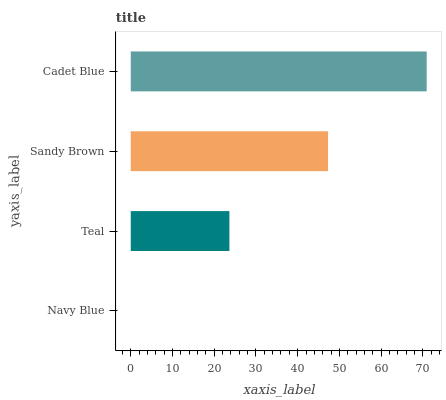Is Navy Blue the minimum?
Answer yes or no. Yes. Is Cadet Blue the maximum?
Answer yes or no. Yes. Is Teal the minimum?
Answer yes or no. No. Is Teal the maximum?
Answer yes or no. No. Is Teal greater than Navy Blue?
Answer yes or no. Yes. Is Navy Blue less than Teal?
Answer yes or no. Yes. Is Navy Blue greater than Teal?
Answer yes or no. No. Is Teal less than Navy Blue?
Answer yes or no. No. Is Sandy Brown the high median?
Answer yes or no. Yes. Is Teal the low median?
Answer yes or no. Yes. Is Teal the high median?
Answer yes or no. No. Is Sandy Brown the low median?
Answer yes or no. No. 